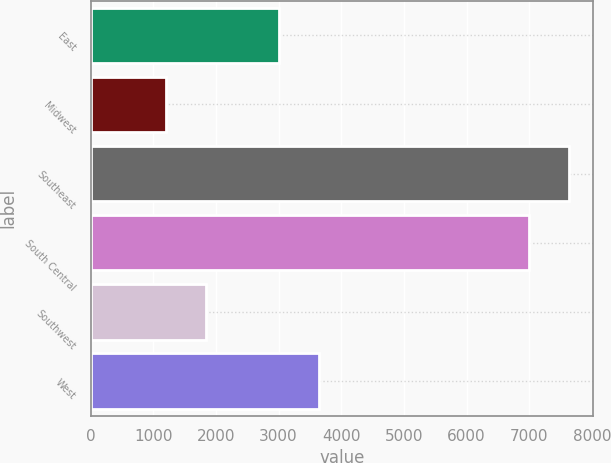Convert chart to OTSL. <chart><loc_0><loc_0><loc_500><loc_500><bar_chart><fcel>East<fcel>Midwest<fcel>Southeast<fcel>South Central<fcel>Southwest<fcel>West<nl><fcel>3000<fcel>1200<fcel>7640<fcel>7000<fcel>1840<fcel>3640<nl></chart> 